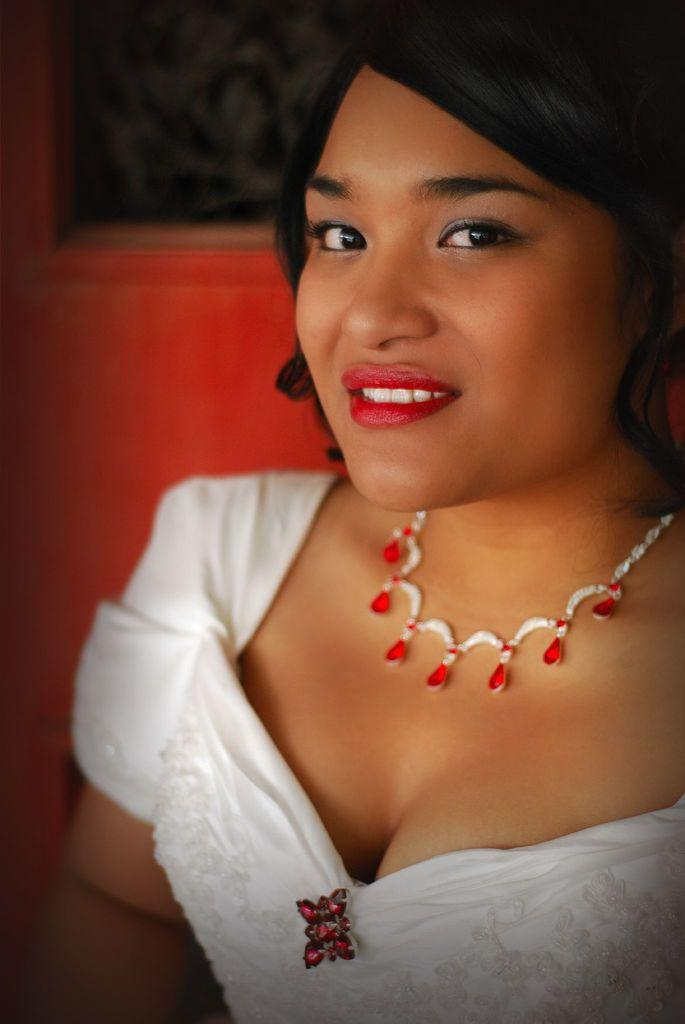Who is the main subject in the image? There is a woman in the image. What is the woman wearing? The woman is wearing a white dress. What is the woman's facial expression in the image? The woman is smiling. What is the woman doing in the image? The woman is posing for the picture. What can be seen in the background of the image? There is a red object in the background, which seems to be a door. What type of dinosaurs can be seen in the image? There are no dinosaurs present in the image. What is the range of the woman's smile in the image? The image does not provide information about the range of the woman's smile. 